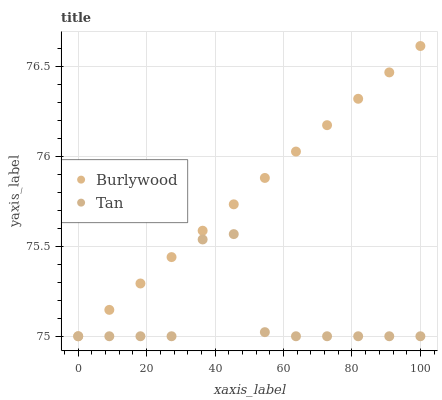Does Tan have the minimum area under the curve?
Answer yes or no. Yes. Does Burlywood have the maximum area under the curve?
Answer yes or no. Yes. Does Tan have the maximum area under the curve?
Answer yes or no. No. Is Burlywood the smoothest?
Answer yes or no. Yes. Is Tan the roughest?
Answer yes or no. Yes. Is Tan the smoothest?
Answer yes or no. No. Does Burlywood have the lowest value?
Answer yes or no. Yes. Does Burlywood have the highest value?
Answer yes or no. Yes. Does Tan have the highest value?
Answer yes or no. No. Does Tan intersect Burlywood?
Answer yes or no. Yes. Is Tan less than Burlywood?
Answer yes or no. No. Is Tan greater than Burlywood?
Answer yes or no. No. 